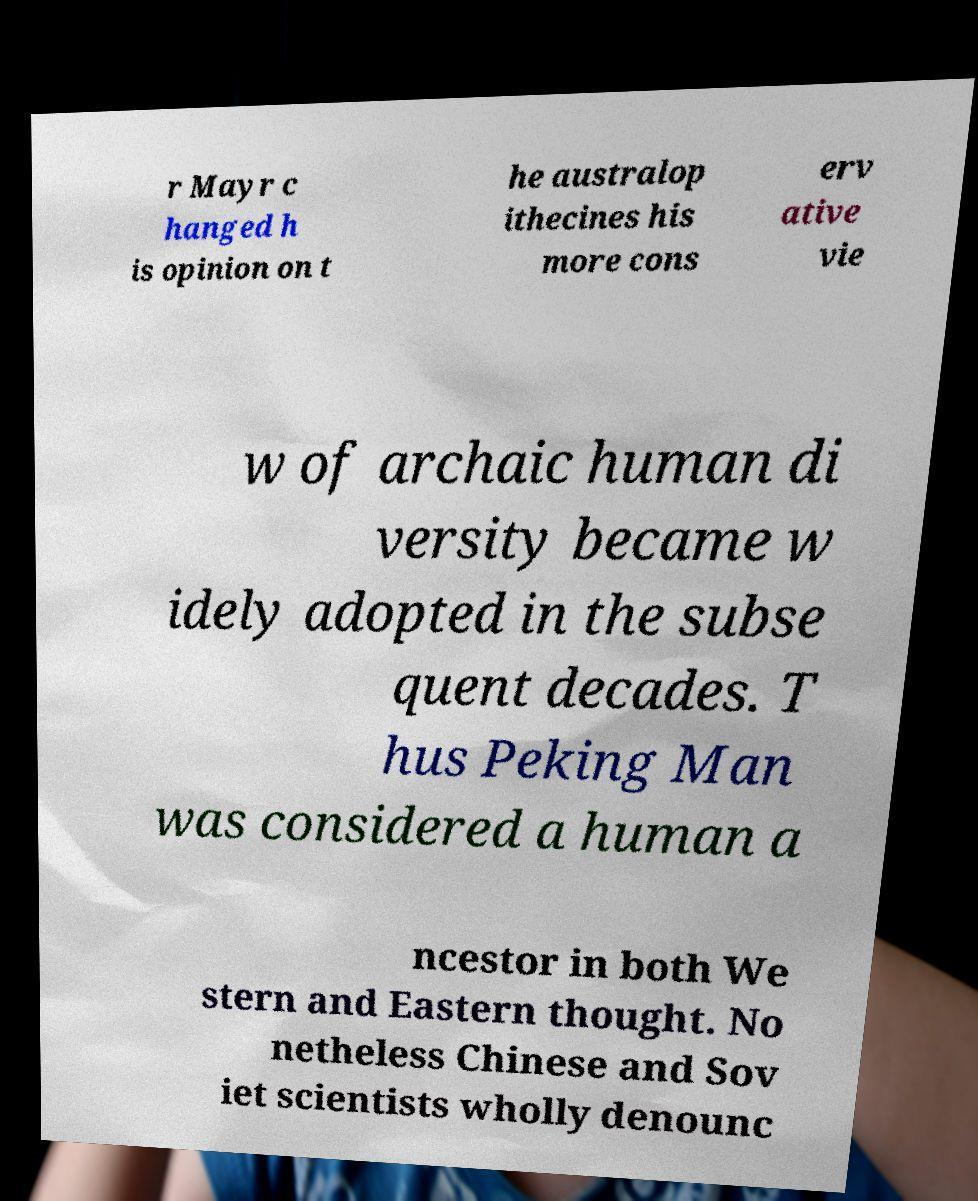Please read and relay the text visible in this image. What does it say? r Mayr c hanged h is opinion on t he australop ithecines his more cons erv ative vie w of archaic human di versity became w idely adopted in the subse quent decades. T hus Peking Man was considered a human a ncestor in both We stern and Eastern thought. No netheless Chinese and Sov iet scientists wholly denounc 